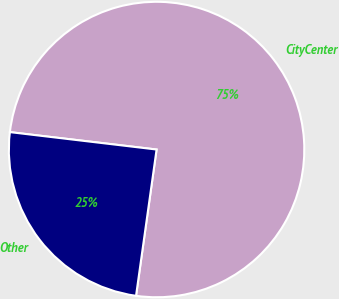<chart> <loc_0><loc_0><loc_500><loc_500><pie_chart><fcel>CityCenter<fcel>Other<nl><fcel>75.34%<fcel>24.66%<nl></chart> 